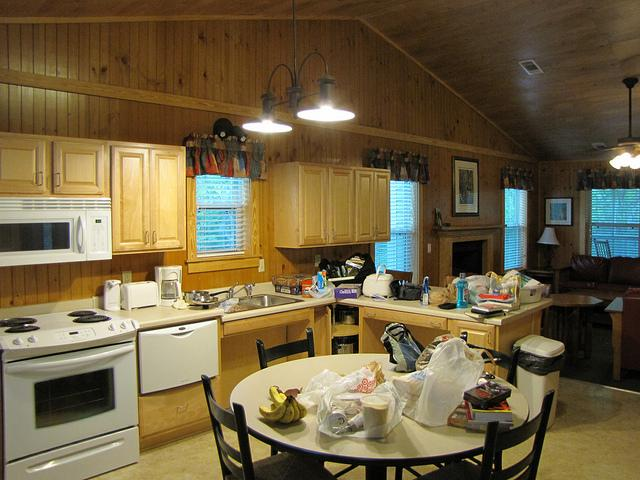What did the occupants of this home likely just get done doing? grocery shopping 